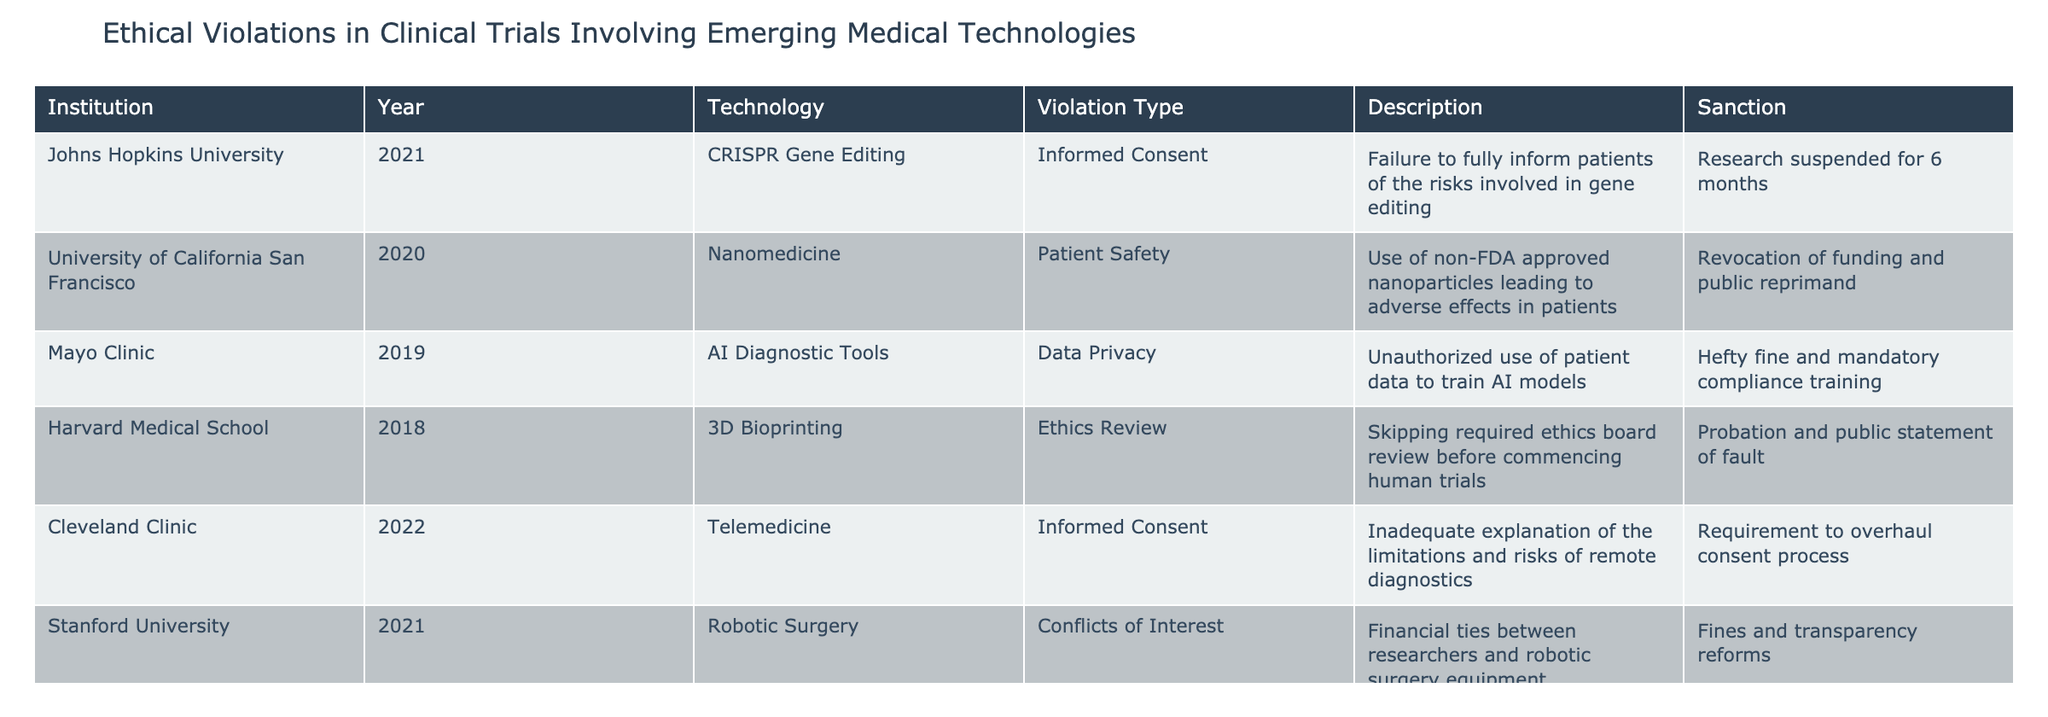What institution experienced a violation related to AI Diagnostic Tools? By examining the table, we can see that Mayo Clinic is listed under the "Institution" column with the "Technology" as AI Diagnostic Tools and the "Violation Type" as Data Privacy.
Answer: Mayo Clinic How many institutions faced violations regarding Informed Consent? The table shows that there are two institutions listed under the "Violation Type" of Informed Consent, which are Johns Hopkins University and Cleveland Clinic.
Answer: 2 Which technology had a sanction of probation and public statement of fault? Looking through the table, Harvard Medical School, which is associated with 3D Bioprinting, received a sanction of probation and public statement of fault for skipping required ethics board review.
Answer: 3D Bioprinting Did the University of Tokyo face any violations related to patient safety? In the table, there is no entry for the University of Tokyo under the "Violation Type" of Patient Safety. It instead lists Psychological Harm. Therefore, the statement is false.
Answer: No What is the average number of years from 2018 to 2022 for the institutions listed that faced ethical violations? The years listed are 2021, 2020, 2019, 2018, 2022, and 2021. To find the average, we first sum these years (2021 + 2020 + 2019 + 2018 + 2022 + 2021) = 12101. There are 6 entries, so we divide by 6, giving us 2020.1667. Rounding gives approximately 2020.
Answer: 2020 What violation type is associated with the sanction of a cease and desist order until corrective measures are implemented? The table indicates that the University of Tokyo faced Psychological Harm as the violation type, which resulted in a cease and desist order until corrective measures are implemented.
Answer: Psychological Harm 